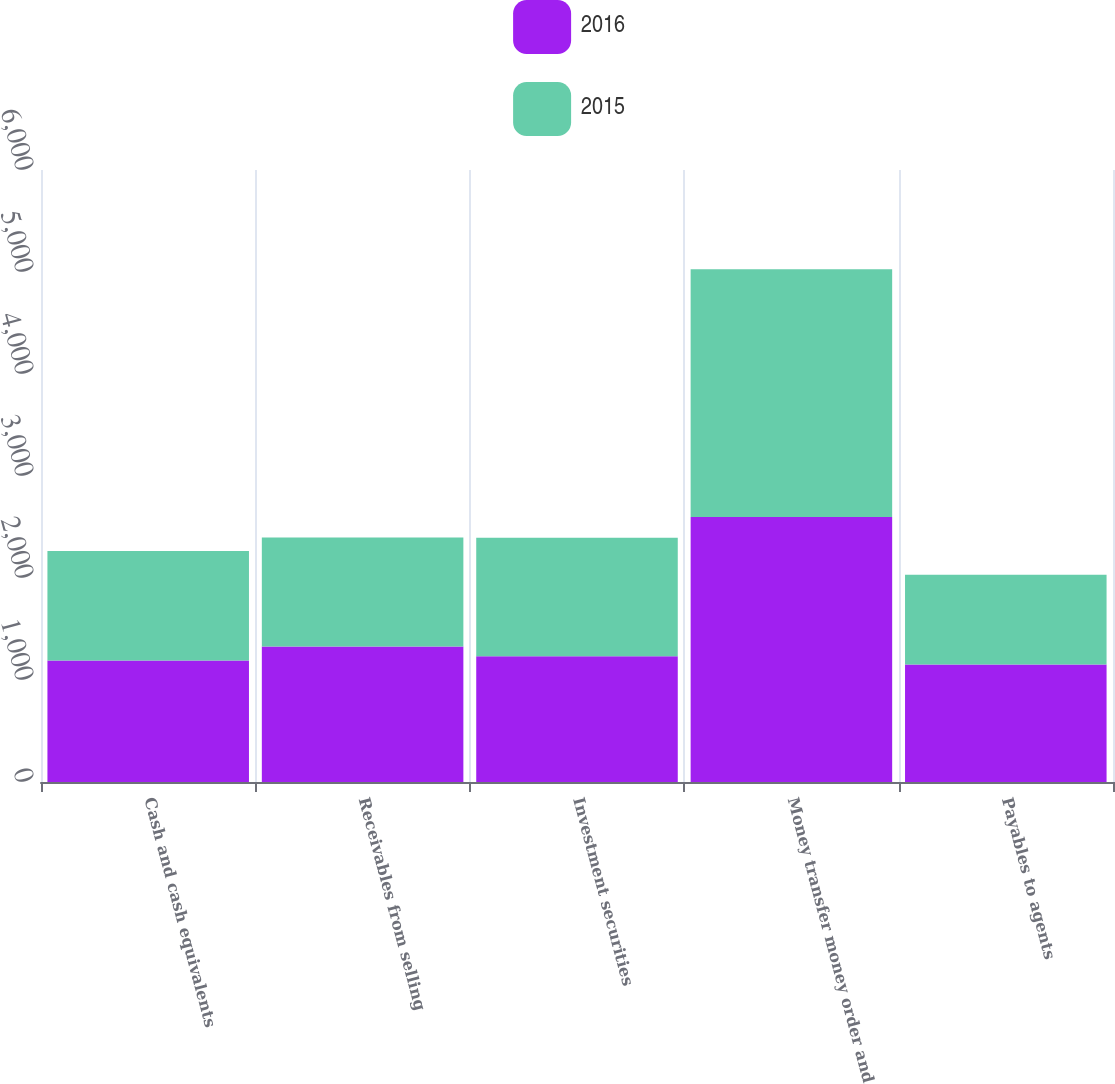Convert chart to OTSL. <chart><loc_0><loc_0><loc_500><loc_500><stacked_bar_chart><ecel><fcel>Cash and cash equivalents<fcel>Receivables from selling<fcel>Investment securities<fcel>Money transfer money order and<fcel>Payables to agents<nl><fcel>2016<fcel>1190<fcel>1327.3<fcel>1231.8<fcel>2598.2<fcel>1150.9<nl><fcel>2015<fcel>1075.7<fcel>1070.4<fcel>1162.6<fcel>2428.5<fcel>880.2<nl></chart> 